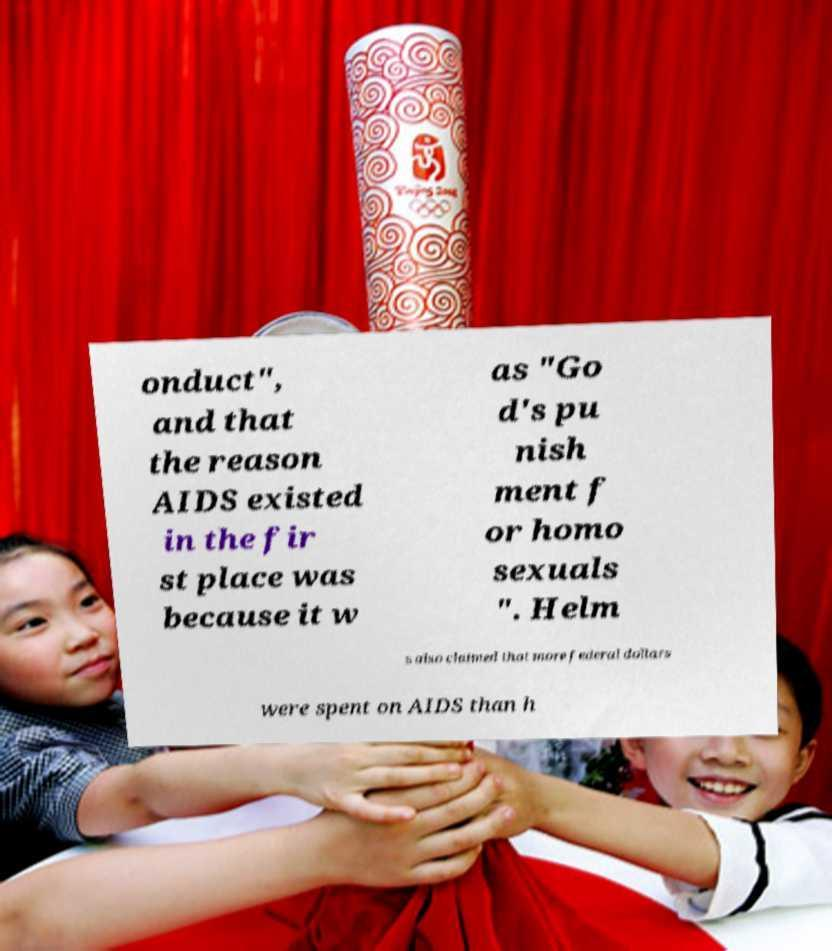Can you read and provide the text displayed in the image?This photo seems to have some interesting text. Can you extract and type it out for me? onduct", and that the reason AIDS existed in the fir st place was because it w as "Go d's pu nish ment f or homo sexuals ". Helm s also claimed that more federal dollars were spent on AIDS than h 